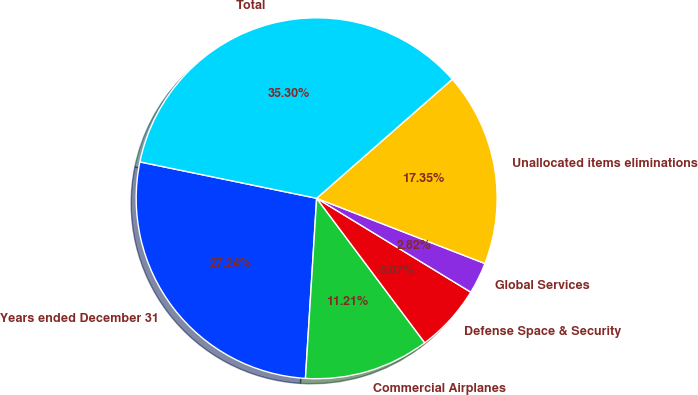<chart> <loc_0><loc_0><loc_500><loc_500><pie_chart><fcel>Years ended December 31<fcel>Commercial Airplanes<fcel>Defense Space & Security<fcel>Global Services<fcel>Unallocated items eliminations<fcel>Total<nl><fcel>27.24%<fcel>11.21%<fcel>6.07%<fcel>2.82%<fcel>17.35%<fcel>35.3%<nl></chart> 